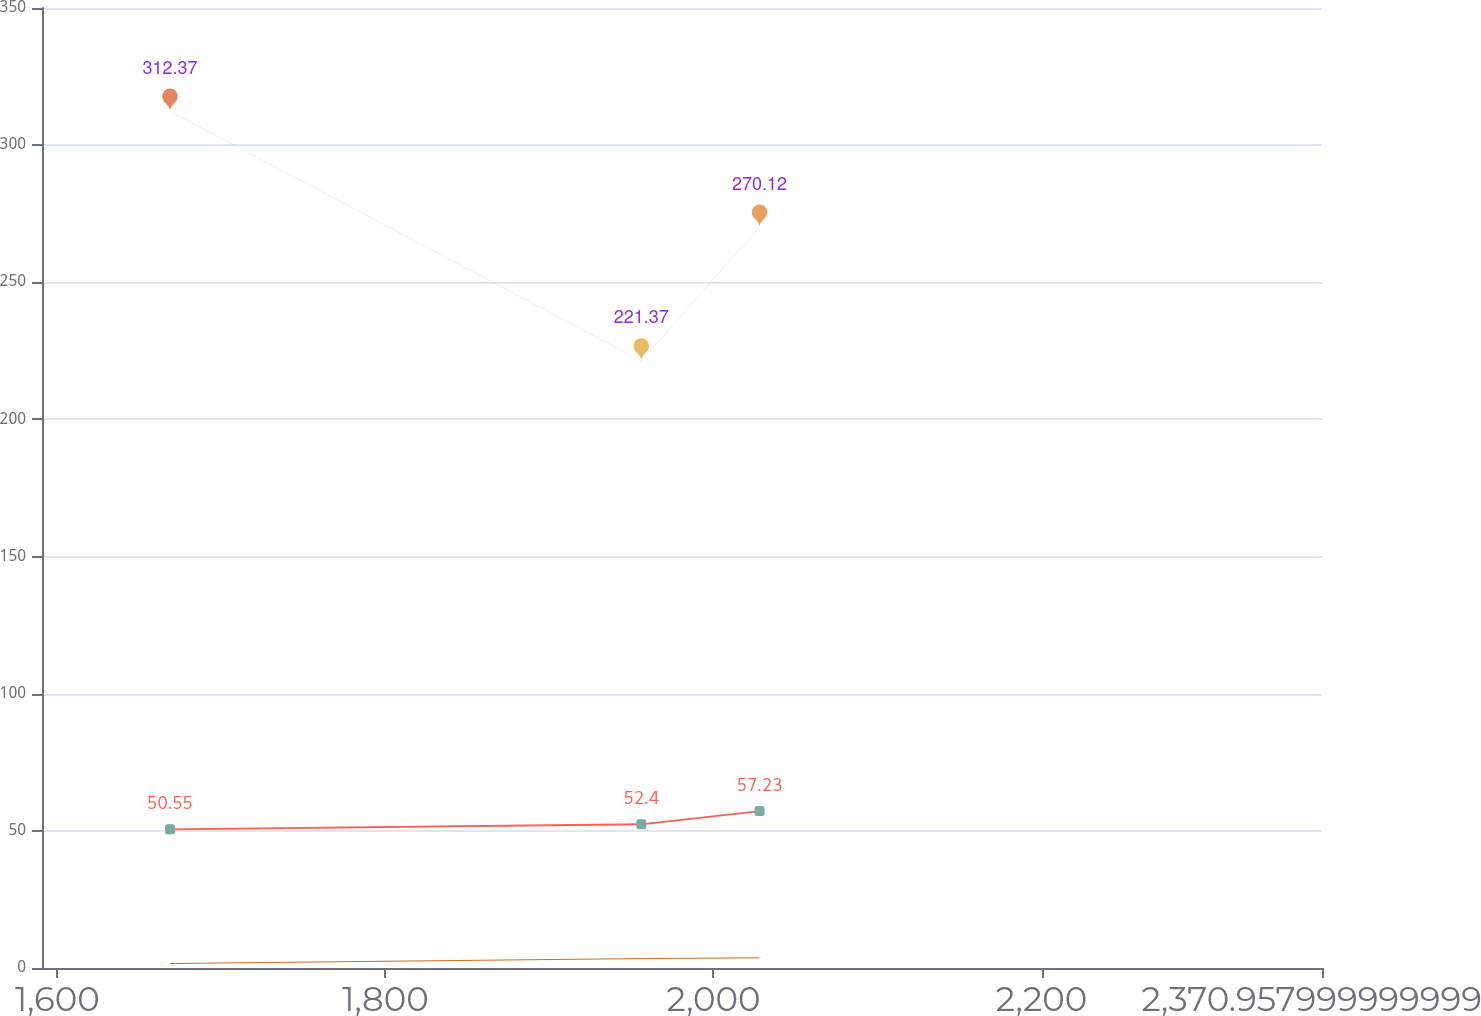<chart> <loc_0><loc_0><loc_500><loc_500><line_chart><ecel><fcel>Gross Medicare Part D (receipts)<fcel>Gross benefit payments<fcel>Pension benefits<nl><fcel>1668.67<fcel>312.37<fcel>50.55<fcel>1.63<nl><fcel>1955.98<fcel>221.37<fcel>52.4<fcel>3.44<nl><fcel>2028.08<fcel>270.12<fcel>57.23<fcel>3.72<nl><fcel>2376.89<fcel>352.94<fcel>64.95<fcel>3.16<nl><fcel>2448.99<fcel>405.31<fcel>69.08<fcel>4.39<nl></chart> 